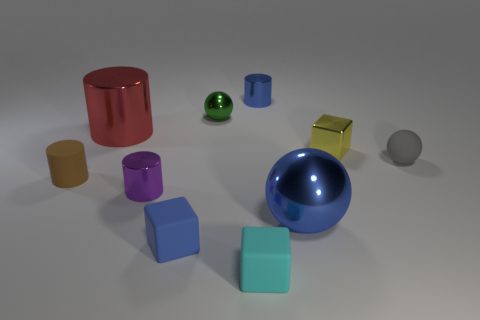What size is the blue metallic cylinder?
Your answer should be compact. Small. Does the small gray sphere have the same material as the big thing left of the small green metal object?
Give a very brief answer. No. Is there a large brown thing of the same shape as the tiny green metal thing?
Offer a terse response. No. What is the material of the yellow object that is the same size as the brown thing?
Your answer should be compact. Metal. There is a blue object that is on the left side of the tiny cyan rubber thing; what size is it?
Offer a terse response. Small. Is the size of the shiny ball that is in front of the red cylinder the same as the rubber object that is on the right side of the blue cylinder?
Give a very brief answer. No. What number of large red cylinders have the same material as the yellow object?
Provide a succinct answer. 1. What is the color of the small matte sphere?
Make the answer very short. Gray. Are there any tiny gray things behind the tiny cyan thing?
Your answer should be compact. Yes. Do the tiny rubber sphere and the tiny matte cylinder have the same color?
Ensure brevity in your answer.  No. 